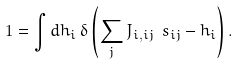<formula> <loc_0><loc_0><loc_500><loc_500>1 = \int d h _ { i } \, \delta \left ( \sum _ { j } J _ { i , i j } \ s _ { i j } - h _ { i } \right ) .</formula> 